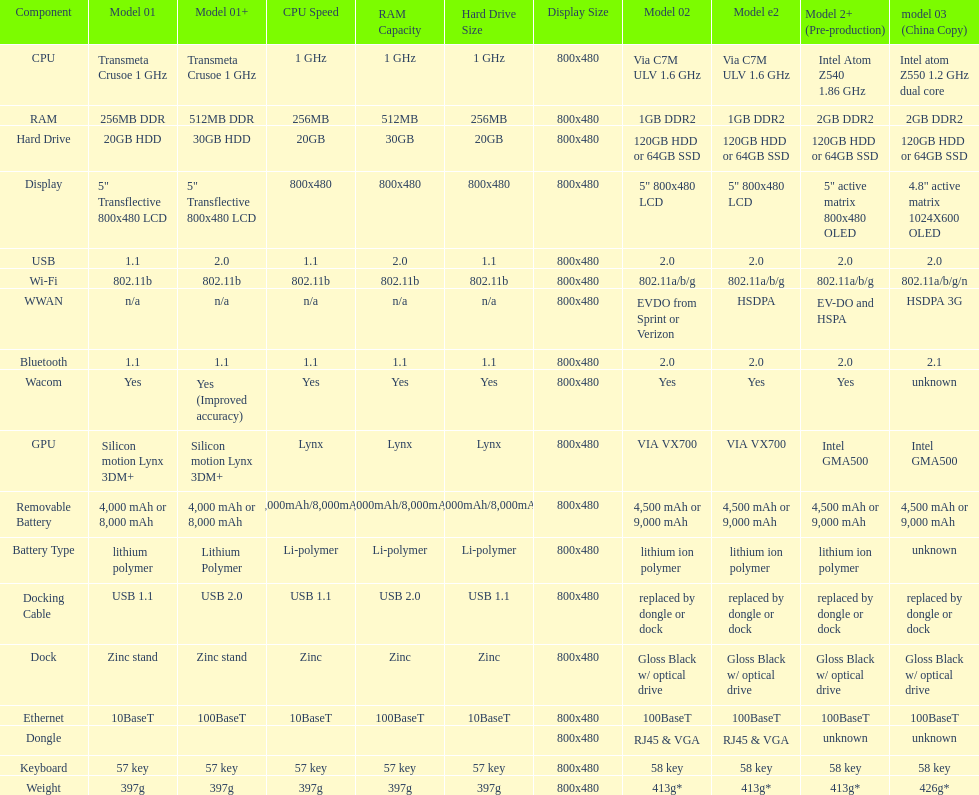Which model weighs the most, according to the table? Model 03 (china copy). 